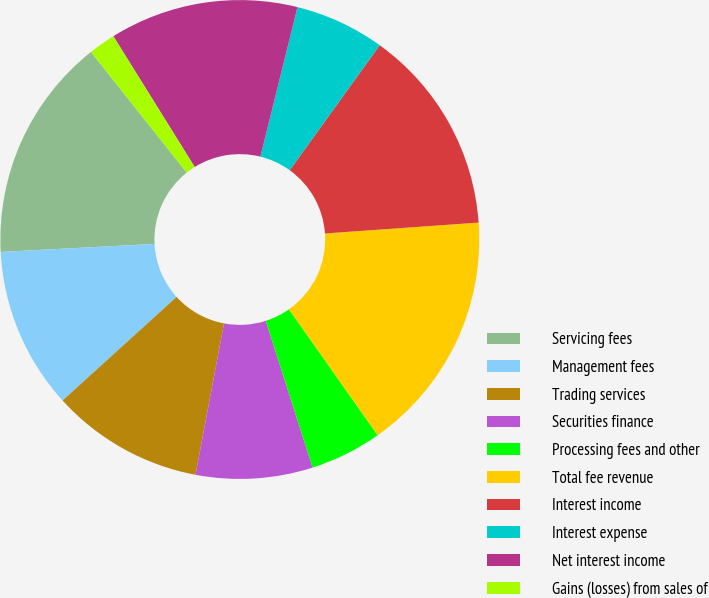<chart> <loc_0><loc_0><loc_500><loc_500><pie_chart><fcel>Servicing fees<fcel>Management fees<fcel>Trading services<fcel>Securities finance<fcel>Processing fees and other<fcel>Total fee revenue<fcel>Interest income<fcel>Interest expense<fcel>Net interest income<fcel>Gains (losses) from sales of<nl><fcel>15.15%<fcel>10.91%<fcel>10.3%<fcel>7.88%<fcel>4.85%<fcel>16.36%<fcel>13.94%<fcel>6.06%<fcel>12.73%<fcel>1.82%<nl></chart> 